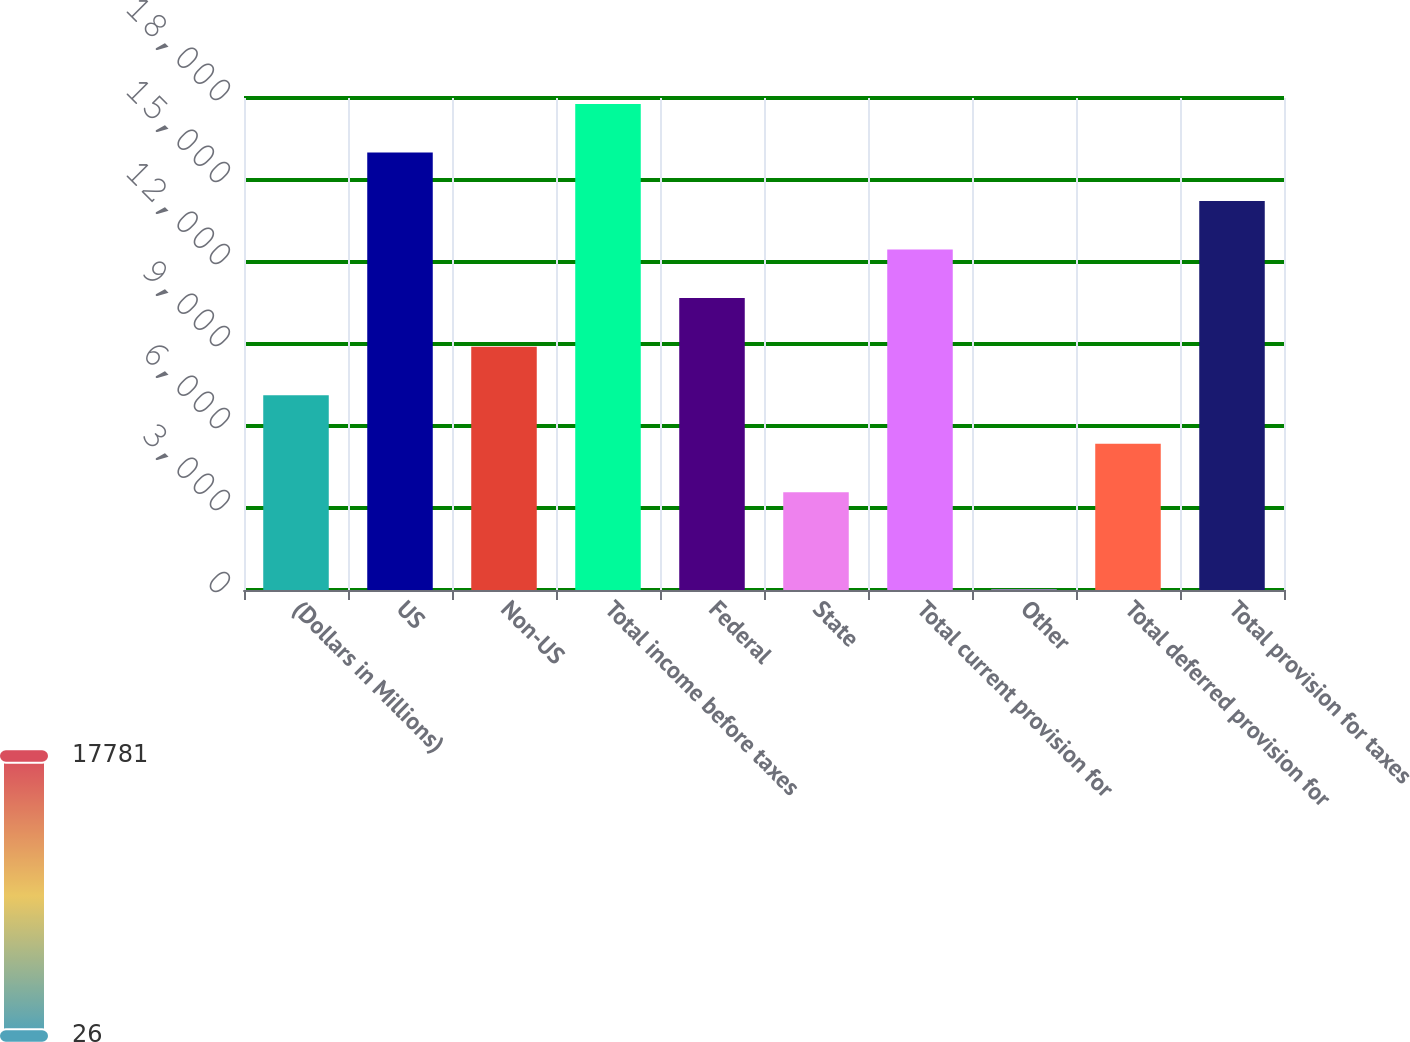Convert chart. <chart><loc_0><loc_0><loc_500><loc_500><bar_chart><fcel>(Dollars in Millions)<fcel>US<fcel>Non-US<fcel>Total income before taxes<fcel>Federal<fcel>State<fcel>Total current provision for<fcel>Other<fcel>Total deferred provision for<fcel>Total provision for taxes<nl><fcel>7128<fcel>16005.5<fcel>8903.5<fcel>17781<fcel>10679<fcel>3577<fcel>12454.5<fcel>26<fcel>5352.5<fcel>14230<nl></chart> 